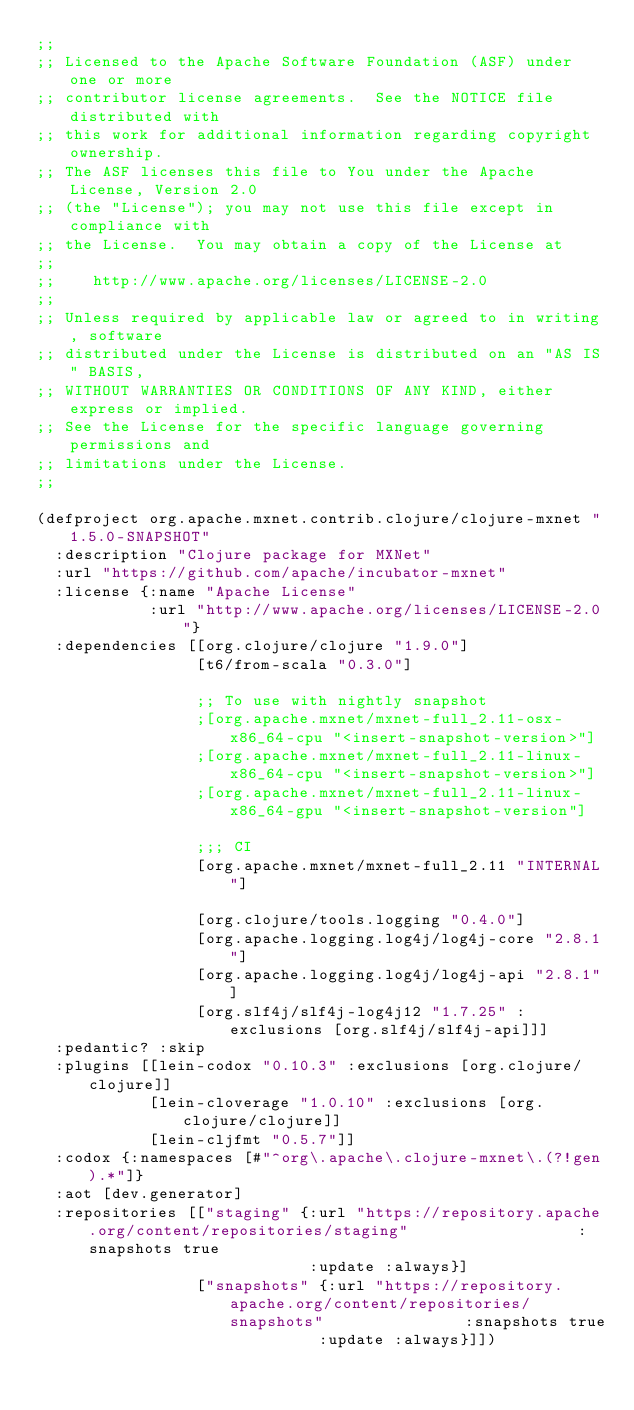Convert code to text. <code><loc_0><loc_0><loc_500><loc_500><_Clojure_>;;
;; Licensed to the Apache Software Foundation (ASF) under one or more
;; contributor license agreements.  See the NOTICE file distributed with
;; this work for additional information regarding copyright ownership.
;; The ASF licenses this file to You under the Apache License, Version 2.0
;; (the "License"); you may not use this file except in compliance with
;; the License.  You may obtain a copy of the License at
;;
;;    http://www.apache.org/licenses/LICENSE-2.0
;;
;; Unless required by applicable law or agreed to in writing, software
;; distributed under the License is distributed on an "AS IS" BASIS,
;; WITHOUT WARRANTIES OR CONDITIONS OF ANY KIND, either express or implied.
;; See the License for the specific language governing permissions and
;; limitations under the License.
;;

(defproject org.apache.mxnet.contrib.clojure/clojure-mxnet "1.5.0-SNAPSHOT"
  :description "Clojure package for MXNet"
  :url "https://github.com/apache/incubator-mxnet"
  :license {:name "Apache License"
            :url "http://www.apache.org/licenses/LICENSE-2.0"}
  :dependencies [[org.clojure/clojure "1.9.0"]
                 [t6/from-scala "0.3.0"]

                 ;; To use with nightly snapshot
                 ;[org.apache.mxnet/mxnet-full_2.11-osx-x86_64-cpu "<insert-snapshot-version>"]
                 ;[org.apache.mxnet/mxnet-full_2.11-linux-x86_64-cpu "<insert-snapshot-version>"]
                 ;[org.apache.mxnet/mxnet-full_2.11-linux-x86_64-gpu "<insert-snapshot-version"]

                 ;;; CI
                 [org.apache.mxnet/mxnet-full_2.11 "INTERNAL"]

                 [org.clojure/tools.logging "0.4.0"]
                 [org.apache.logging.log4j/log4j-core "2.8.1"]
                 [org.apache.logging.log4j/log4j-api "2.8.1"]
                 [org.slf4j/slf4j-log4j12 "1.7.25" :exclusions [org.slf4j/slf4j-api]]]
  :pedantic? :skip
  :plugins [[lein-codox "0.10.3" :exclusions [org.clojure/clojure]]
            [lein-cloverage "1.0.10" :exclusions [org.clojure/clojure]]
            [lein-cljfmt "0.5.7"]]
  :codox {:namespaces [#"^org\.apache\.clojure-mxnet\.(?!gen).*"]}
  :aot [dev.generator]
  :repositories [["staging" {:url "https://repository.apache.org/content/repositories/staging"                  :snapshots true
                             :update :always}]
                 ["snapshots" {:url "https://repository.apache.org/content/repositories/snapshots"               :snapshots true
                              :update :always}]])
</code> 